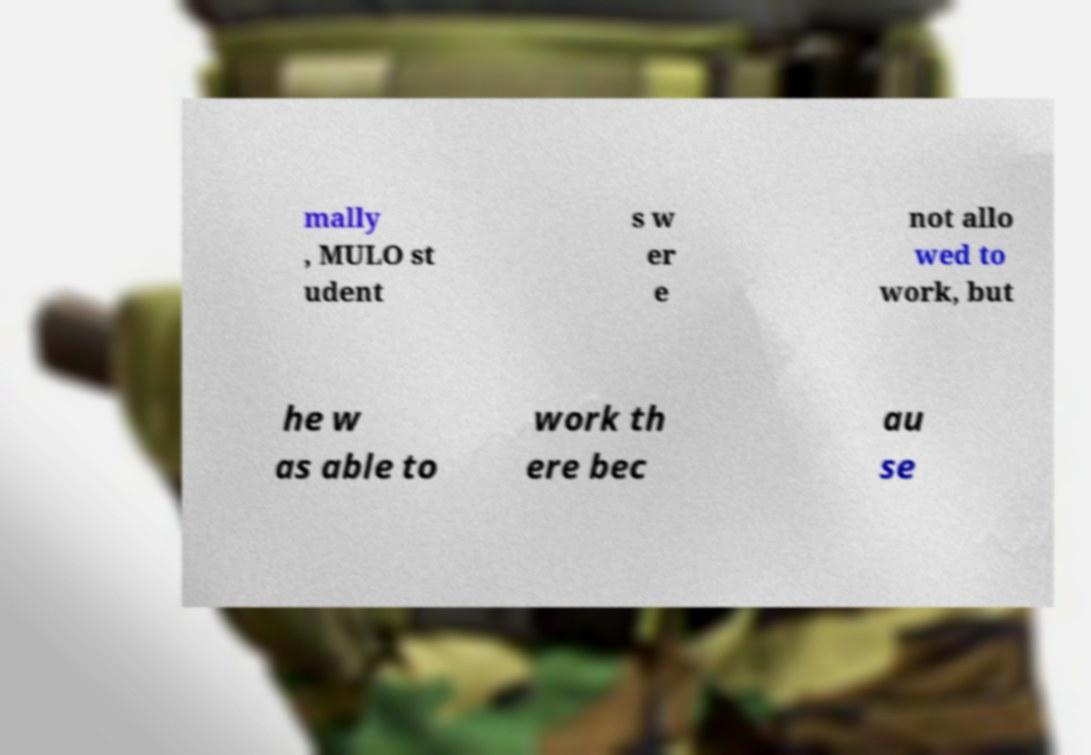Could you assist in decoding the text presented in this image and type it out clearly? mally , MULO st udent s w er e not allo wed to work, but he w as able to work th ere bec au se 